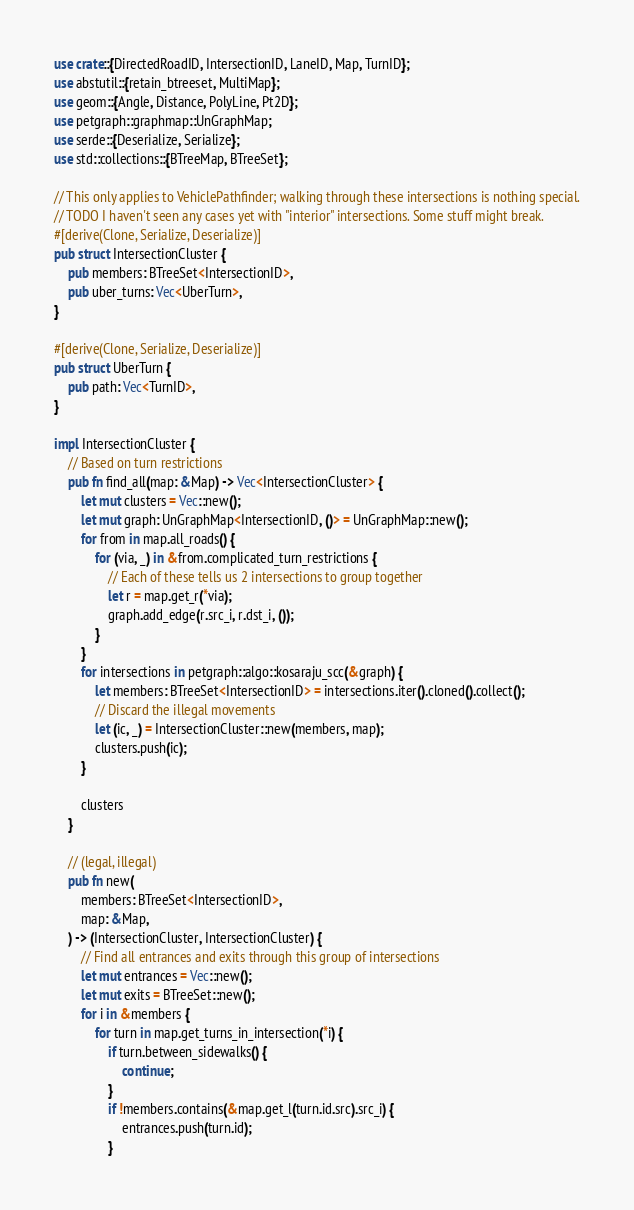<code> <loc_0><loc_0><loc_500><loc_500><_Rust_>use crate::{DirectedRoadID, IntersectionID, LaneID, Map, TurnID};
use abstutil::{retain_btreeset, MultiMap};
use geom::{Angle, Distance, PolyLine, Pt2D};
use petgraph::graphmap::UnGraphMap;
use serde::{Deserialize, Serialize};
use std::collections::{BTreeMap, BTreeSet};

// This only applies to VehiclePathfinder; walking through these intersections is nothing special.
// TODO I haven't seen any cases yet with "interior" intersections. Some stuff might break.
#[derive(Clone, Serialize, Deserialize)]
pub struct IntersectionCluster {
    pub members: BTreeSet<IntersectionID>,
    pub uber_turns: Vec<UberTurn>,
}

#[derive(Clone, Serialize, Deserialize)]
pub struct UberTurn {
    pub path: Vec<TurnID>,
}

impl IntersectionCluster {
    // Based on turn restrictions
    pub fn find_all(map: &Map) -> Vec<IntersectionCluster> {
        let mut clusters = Vec::new();
        let mut graph: UnGraphMap<IntersectionID, ()> = UnGraphMap::new();
        for from in map.all_roads() {
            for (via, _) in &from.complicated_turn_restrictions {
                // Each of these tells us 2 intersections to group together
                let r = map.get_r(*via);
                graph.add_edge(r.src_i, r.dst_i, ());
            }
        }
        for intersections in petgraph::algo::kosaraju_scc(&graph) {
            let members: BTreeSet<IntersectionID> = intersections.iter().cloned().collect();
            // Discard the illegal movements
            let (ic, _) = IntersectionCluster::new(members, map);
            clusters.push(ic);
        }

        clusters
    }

    // (legal, illegal)
    pub fn new(
        members: BTreeSet<IntersectionID>,
        map: &Map,
    ) -> (IntersectionCluster, IntersectionCluster) {
        // Find all entrances and exits through this group of intersections
        let mut entrances = Vec::new();
        let mut exits = BTreeSet::new();
        for i in &members {
            for turn in map.get_turns_in_intersection(*i) {
                if turn.between_sidewalks() {
                    continue;
                }
                if !members.contains(&map.get_l(turn.id.src).src_i) {
                    entrances.push(turn.id);
                }</code> 